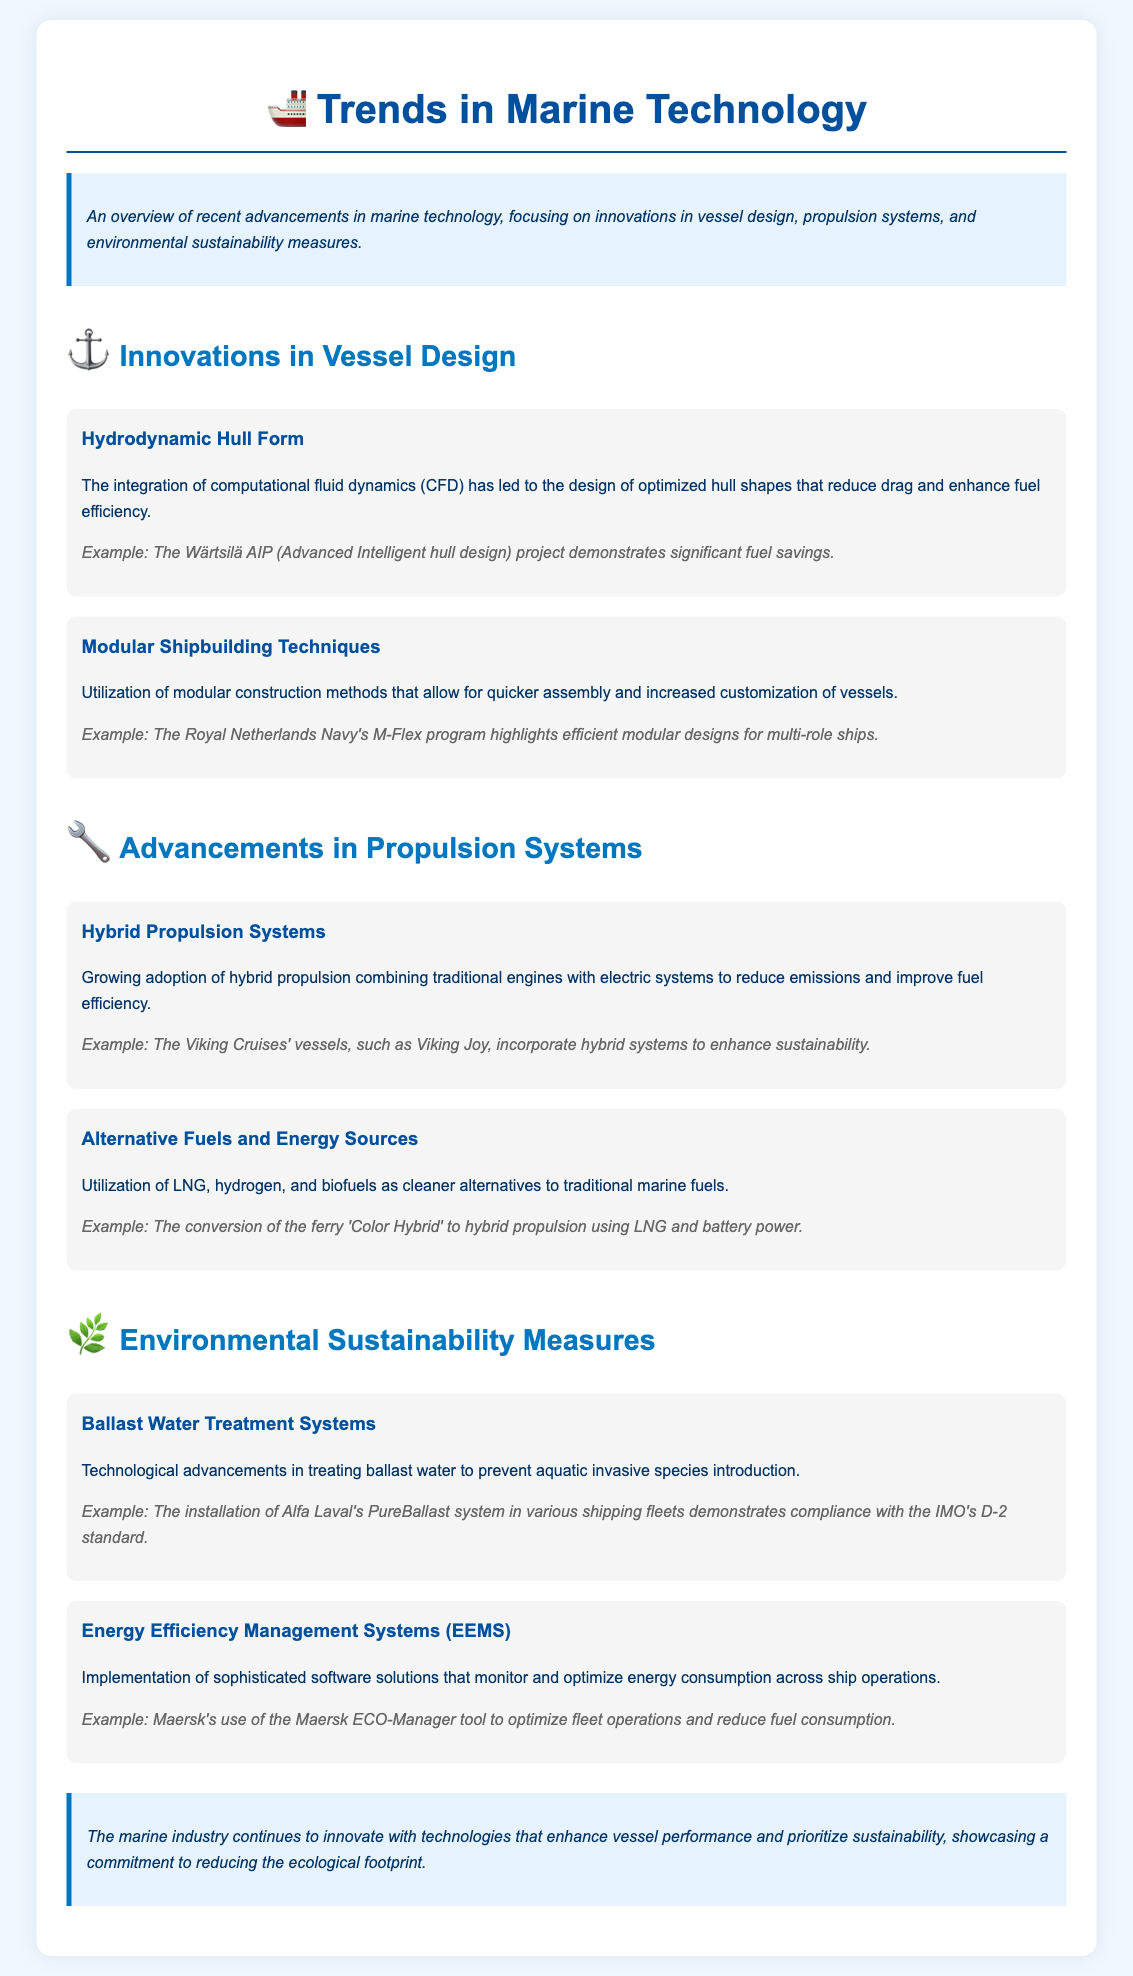What is the focus of the document? The document provides an overview of recent advancements in marine technology, specifically innovations in vessel design, propulsion systems, and environmental sustainability measures.
Answer: advancements in marine technology What is one example of a hydrodynamic hull form project? The document mentions the Wärtsilä AIP project as a significant example of optimized hull shape design leading to fuel savings.
Answer: Wärtsilä AIP What type of propulsion system is increasingly adopted in the industry? The document discusses the growing adoption of hybrid propulsion systems combining traditional engines with electric systems.
Answer: hybrid propulsion systems What is the purpose of ballast water treatment systems? The purpose of ballast water treatment systems is to prevent aquatic invasive species introduction.
Answer: prevent aquatic invasive species Which tool does Maersk use to optimize fleet operations? The document states that Maersk utilizes the Maersk ECO-Manager tool for monitoring and optimizing energy consumption.
Answer: Maersk ECO-Manager What does the Royal Netherlands Navy's M-Flex program highlight? The M-Flex program demonstrates efficient modular designs for multi-role ships.
Answer: efficient modular designs What alternative fuel is mentioned for cleaner marine fuel use? The document mentions LNG as a cleaner alternative to traditional marine fuels.
Answer: LNG What do Energy Efficiency Management Systems (EEMS) do? EEMS monitor and optimize energy consumption across ship operations.
Answer: monitor and optimize energy consumption 